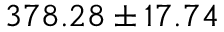Convert formula to latex. <formula><loc_0><loc_0><loc_500><loc_500>3 7 8 . 2 8 \pm 1 7 . 7 4</formula> 